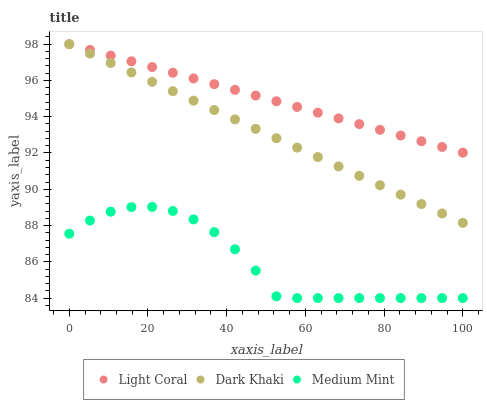Does Medium Mint have the minimum area under the curve?
Answer yes or no. Yes. Does Light Coral have the maximum area under the curve?
Answer yes or no. Yes. Does Dark Khaki have the minimum area under the curve?
Answer yes or no. No. Does Dark Khaki have the maximum area under the curve?
Answer yes or no. No. Is Light Coral the smoothest?
Answer yes or no. Yes. Is Medium Mint the roughest?
Answer yes or no. Yes. Is Dark Khaki the smoothest?
Answer yes or no. No. Is Dark Khaki the roughest?
Answer yes or no. No. Does Medium Mint have the lowest value?
Answer yes or no. Yes. Does Dark Khaki have the lowest value?
Answer yes or no. No. Does Dark Khaki have the highest value?
Answer yes or no. Yes. Does Medium Mint have the highest value?
Answer yes or no. No. Is Medium Mint less than Light Coral?
Answer yes or no. Yes. Is Light Coral greater than Medium Mint?
Answer yes or no. Yes. Does Light Coral intersect Dark Khaki?
Answer yes or no. Yes. Is Light Coral less than Dark Khaki?
Answer yes or no. No. Is Light Coral greater than Dark Khaki?
Answer yes or no. No. Does Medium Mint intersect Light Coral?
Answer yes or no. No. 